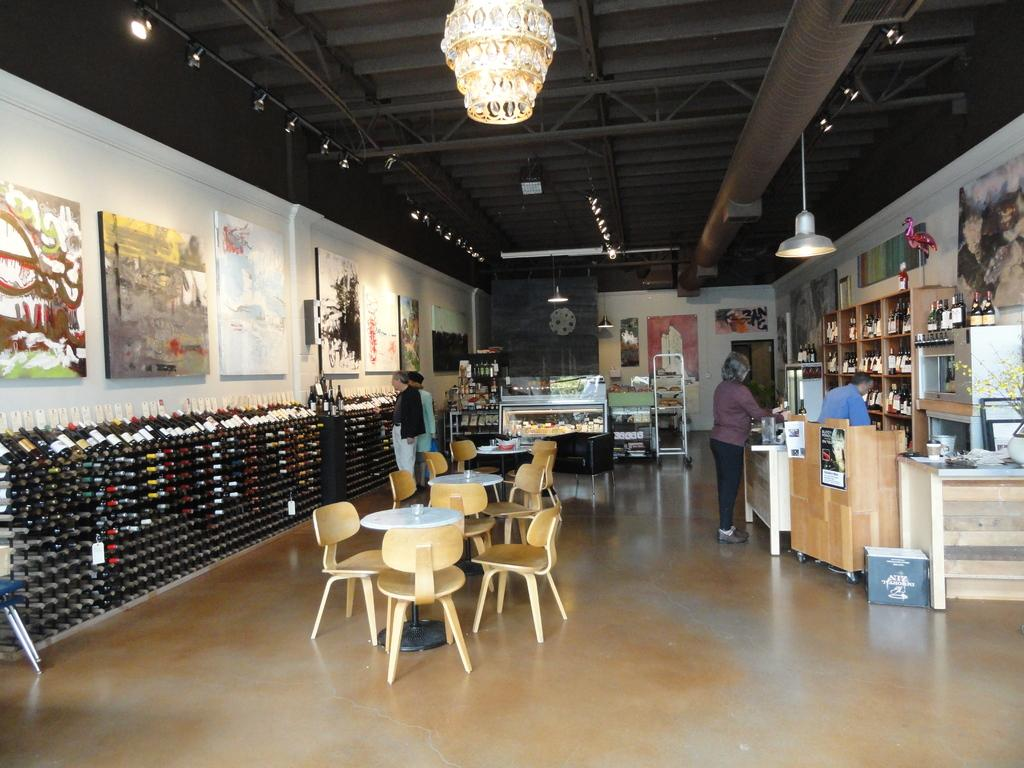What is the gender of the person standing in the image? There is a woman standing in the image. What is the man in the image doing? The man is looking at something in the image. How many people are looking at the scene in the image? There are two persons looking at the scene in the image. What type of furniture arrangement can be seen in the image? There is a table with chair arrangement in the image. What language is the woman speaking in the image? There is no information about the language being spoken in the image. Is there a baseball game happening in the image? There is no indication of a baseball game or any sports-related activity in the image. 